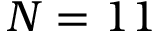Convert formula to latex. <formula><loc_0><loc_0><loc_500><loc_500>N = 1 1</formula> 